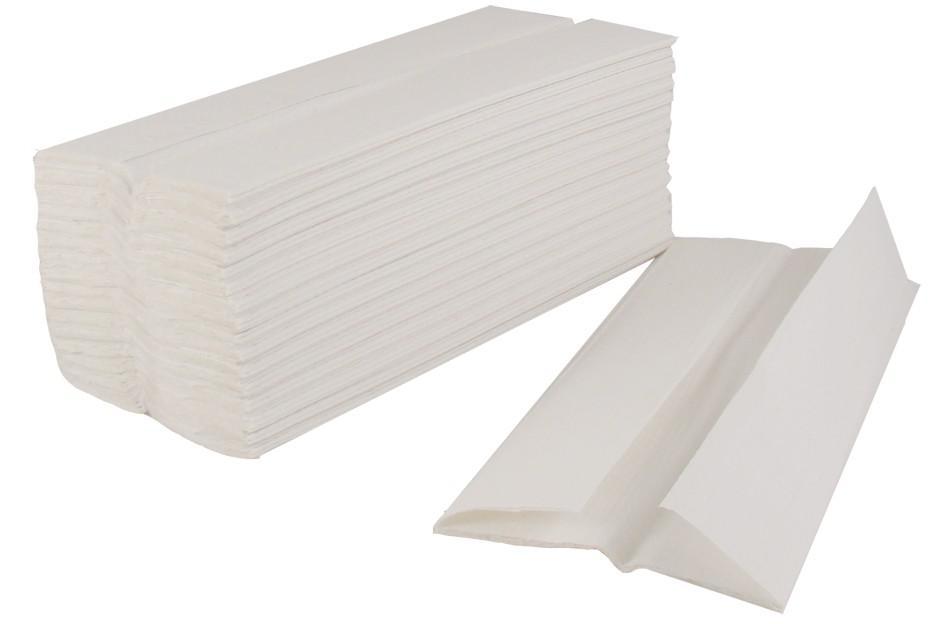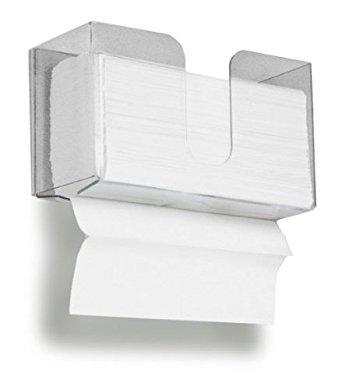The first image is the image on the left, the second image is the image on the right. Analyze the images presented: Is the assertion "The right image shows an opaque gray wall-mount dispenser with a white paper towel hanging below it." valid? Answer yes or no. No. 